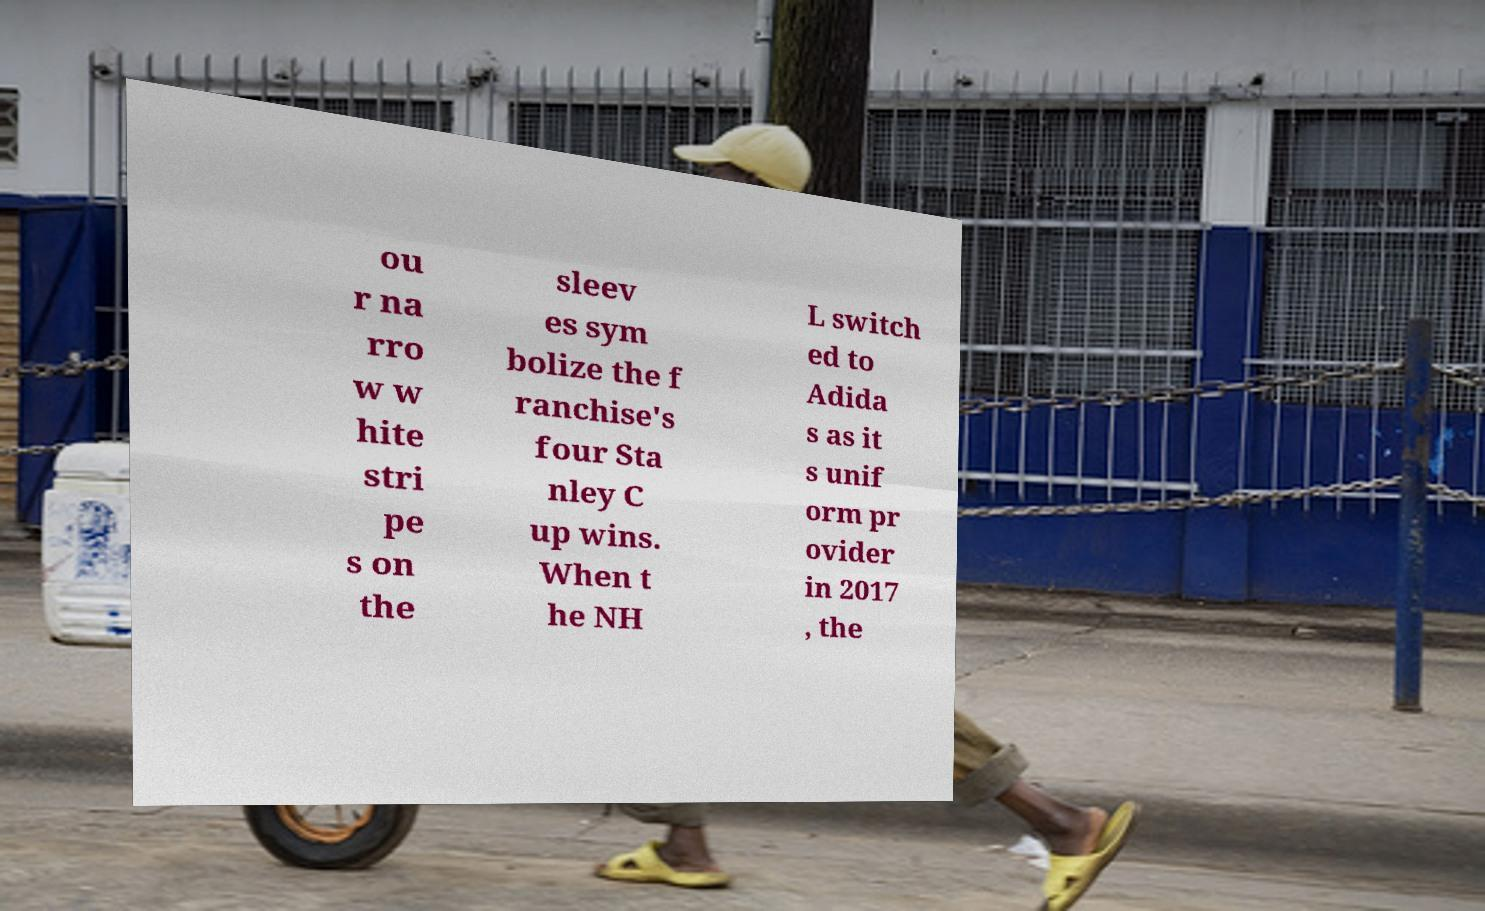Please identify and transcribe the text found in this image. ou r na rro w w hite stri pe s on the sleev es sym bolize the f ranchise's four Sta nley C up wins. When t he NH L switch ed to Adida s as it s unif orm pr ovider in 2017 , the 